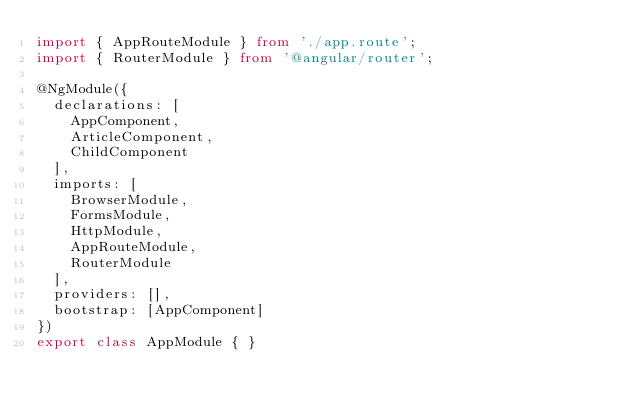<code> <loc_0><loc_0><loc_500><loc_500><_TypeScript_>import { AppRouteModule } from './app.route';
import { RouterModule } from '@angular/router';

@NgModule({
  declarations: [
    AppComponent,
    ArticleComponent,
    ChildComponent
  ],
  imports: [
    BrowserModule,
    FormsModule,
    HttpModule,
    AppRouteModule,
    RouterModule
  ],
  providers: [],
  bootstrap: [AppComponent]
})
export class AppModule { }
</code> 